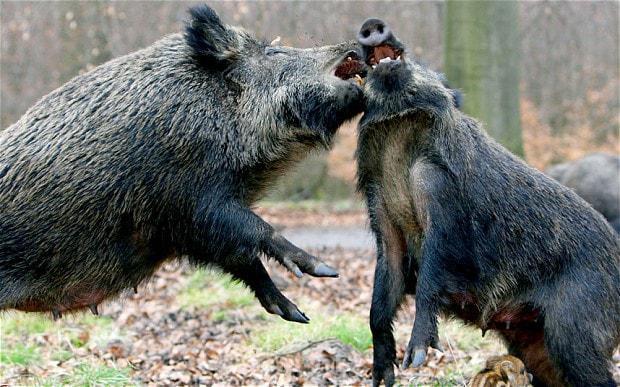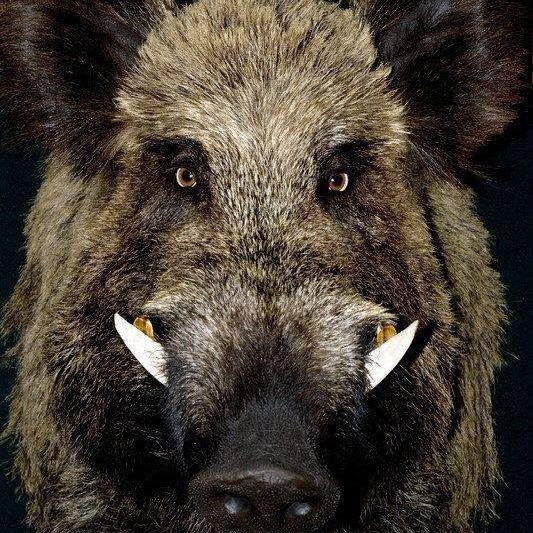The first image is the image on the left, the second image is the image on the right. Evaluate the accuracy of this statement regarding the images: "There are two animals in the picture on the left.". Is it true? Answer yes or no. Yes. 